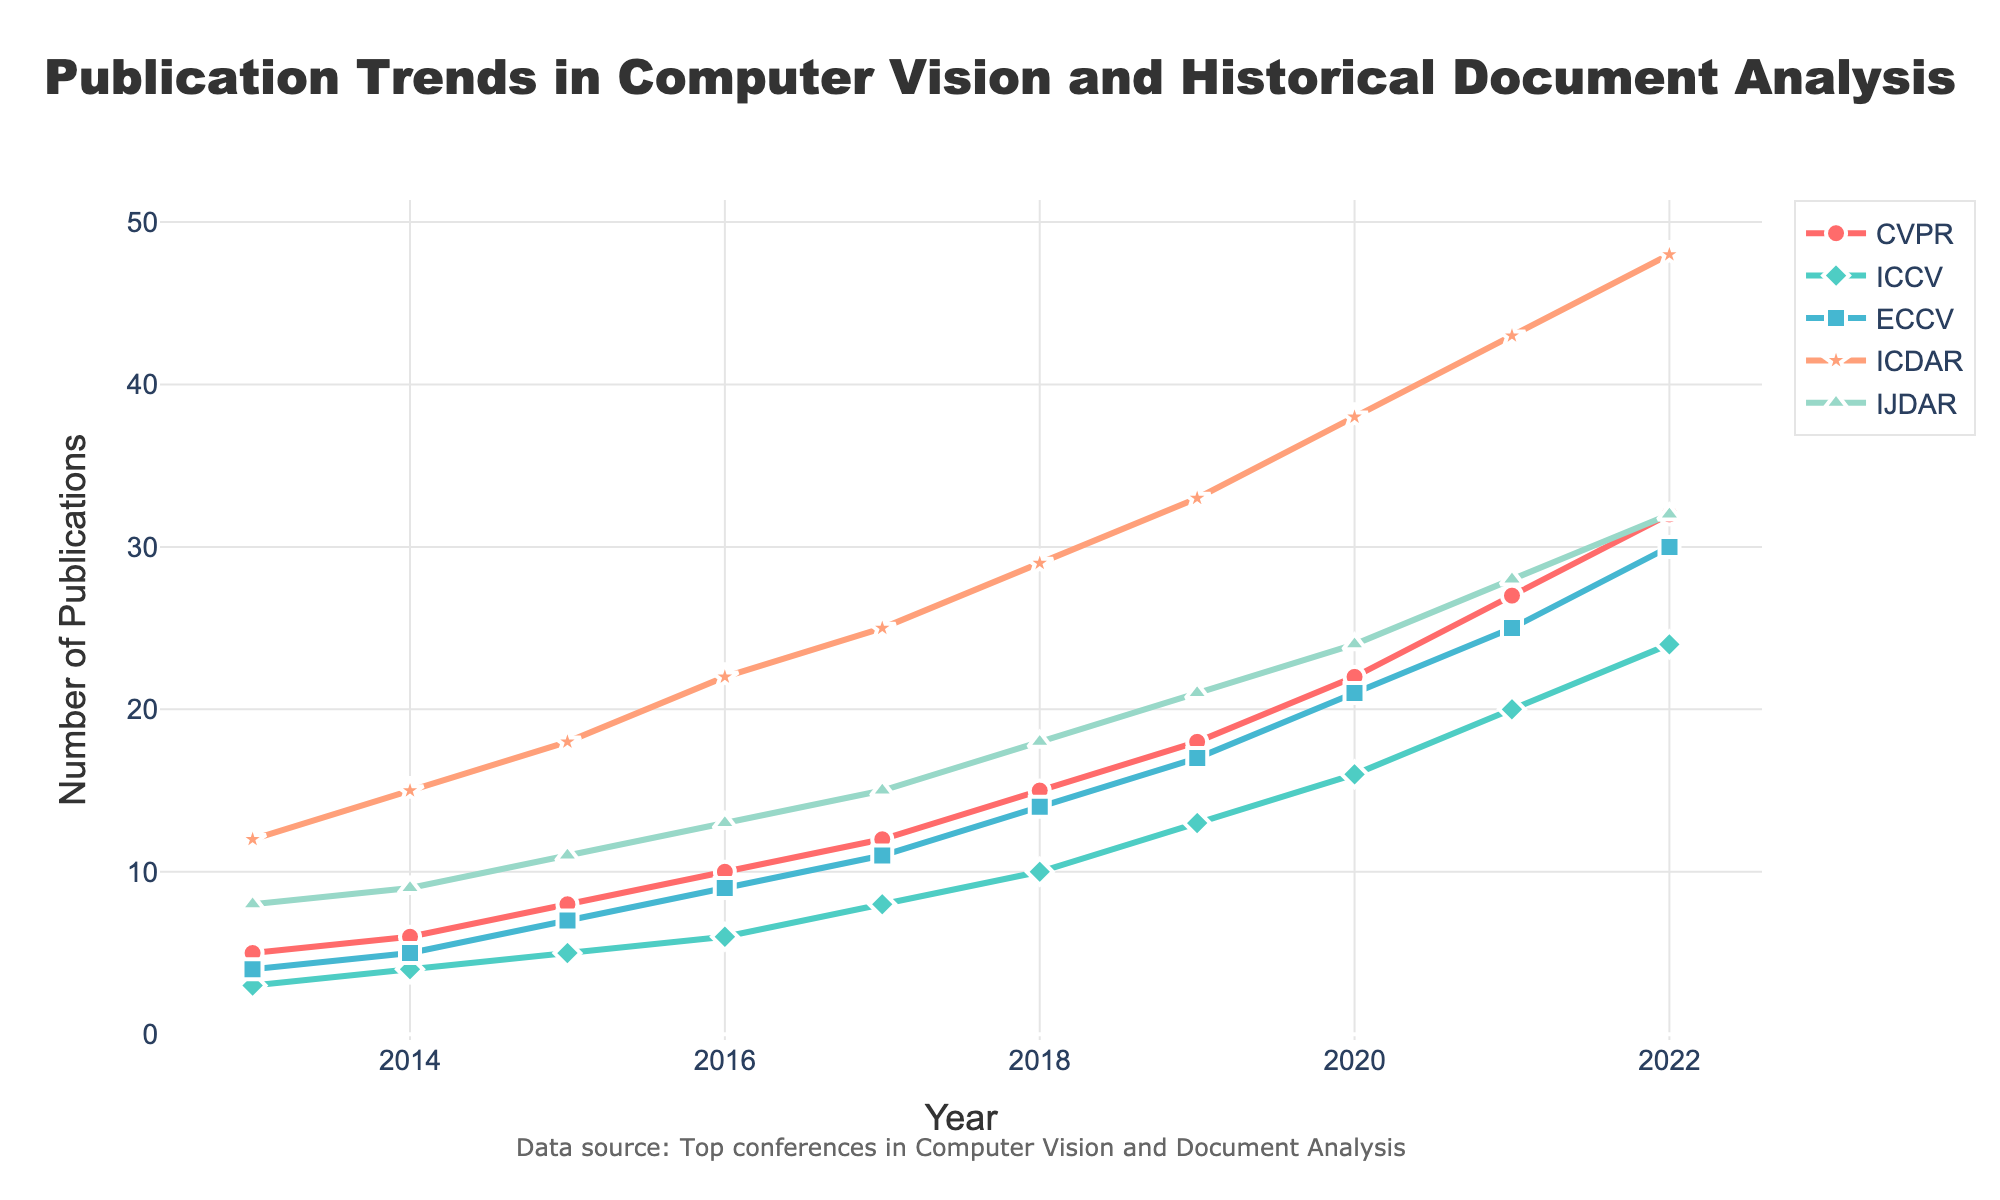Which conference had the most publications in 2022? Look at the year 2022 and compare the publication counts of all conferences. The conference with the highest number of publications in that year is the one with the most.
Answer: ICDAR How did the number of publications in CVPR change from 2013 to 2022? Subtract the number of publications in 2013 from the number of publications in 2022 for CVPR. The change equals the final value minus the initial value, so, 32 - 5 = 27.
Answer: 27 Which conference had the smallest growth in publications from 2013 to 2022? To find the smallest growth, calculate the difference in publication counts for each conference between 2013 and 2022, then compare them. Growth values are: CVPR (32-5=27), ICCV (24-3=21), ECCV (30-4=26), ICDAR (48-12=36), IJDAR (32-8=24). The smallest growth is for ICCV.
Answer: ICCV Which conference shows the most consistent increase in the number of publications over the years? Compare the trend lines for each conference. Consistent increase implies steady and uniform growth. Identify the conference with the overall straightest and most uniformly spaced upward line.
Answer: ICCV In which year did ICDAR see the most significant increase in publications compared to the previous year? Compare year-to-year increases for ICDAR by calculating the difference for each consecutive year and then identify the year with the highest increase. Largest differences: 2021-2020 (43-38=5), thus, 2021.
Answer: 2021 How many total publications were there in IJDAR over the entire period? Sum the number of publications in IJDAR for each year: 8+9+11+13+15+18+21+24+28+32 = 179
Answer: 179 Is there a year in which both CVPR and ICCV had the same number of publications? Compare the publication counts for CVPR and ICCV year by year. They didn’t have the same number of publications in any given year.
Answer: No In 2020, did ECCV have more or fewer publications than ICDAR in 2017? Compare the publication counts of ECCV in 2020 and ICDAR in 2017. ECCV in 2020 had 21 and ICDAR in 2017 had 25. Therefore, ECCV had fewer publications.
Answer: Fewer Which conference had the largest relative increase from 2013 to 2022? Calculate the relative increase (percentage increase) for each conference [(End Value - Start Value) / Start Value * 100] and compare them. Calculations are as follows: CVPR: ((32-5)/5)*100 = 540%, ICCV: ((24-3)/3)*100 = 700%, ECCV: ((30-4)/4)*100 = 650%, ICDAR: ((48-12)/12)*100 = 300%, IJDAR: ((32-8)/8)*100 = 300%. The largest relative increase is for ICCV.
Answer: ICCV What is the average number of publications for any given conference in 2021 across all conferences? Sum the number of publications for all conferences in 2021 and divide by the number of conferences: (27+20+25+43+28)/5 = 28.6
Answer: 28.6 